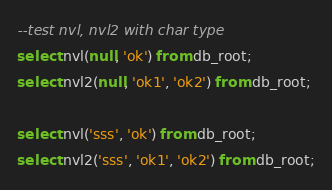<code> <loc_0><loc_0><loc_500><loc_500><_SQL_>--test nvl, nvl2 with char type
select nvl(null, 'ok') from db_root;
select nvl2(null, 'ok1', 'ok2') from db_root;

select nvl('sss', 'ok') from db_root;
select nvl2('sss', 'ok1', 'ok2') from db_root;
</code> 